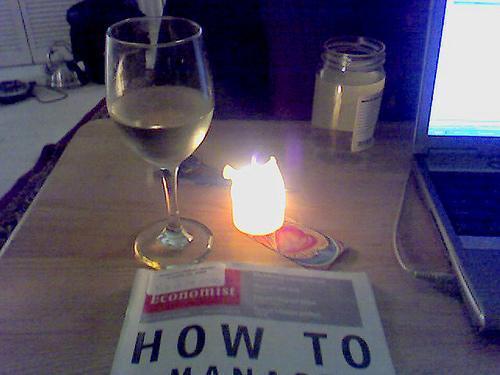How many glasses have something in them?
Give a very brief answer. 1. How many wine glasses are on the table?
Give a very brief answer. 1. How many white wines do you see?
Give a very brief answer. 1. How many bottles can you see?
Give a very brief answer. 1. How many bus riders are leaning out of a bus window?
Give a very brief answer. 0. 